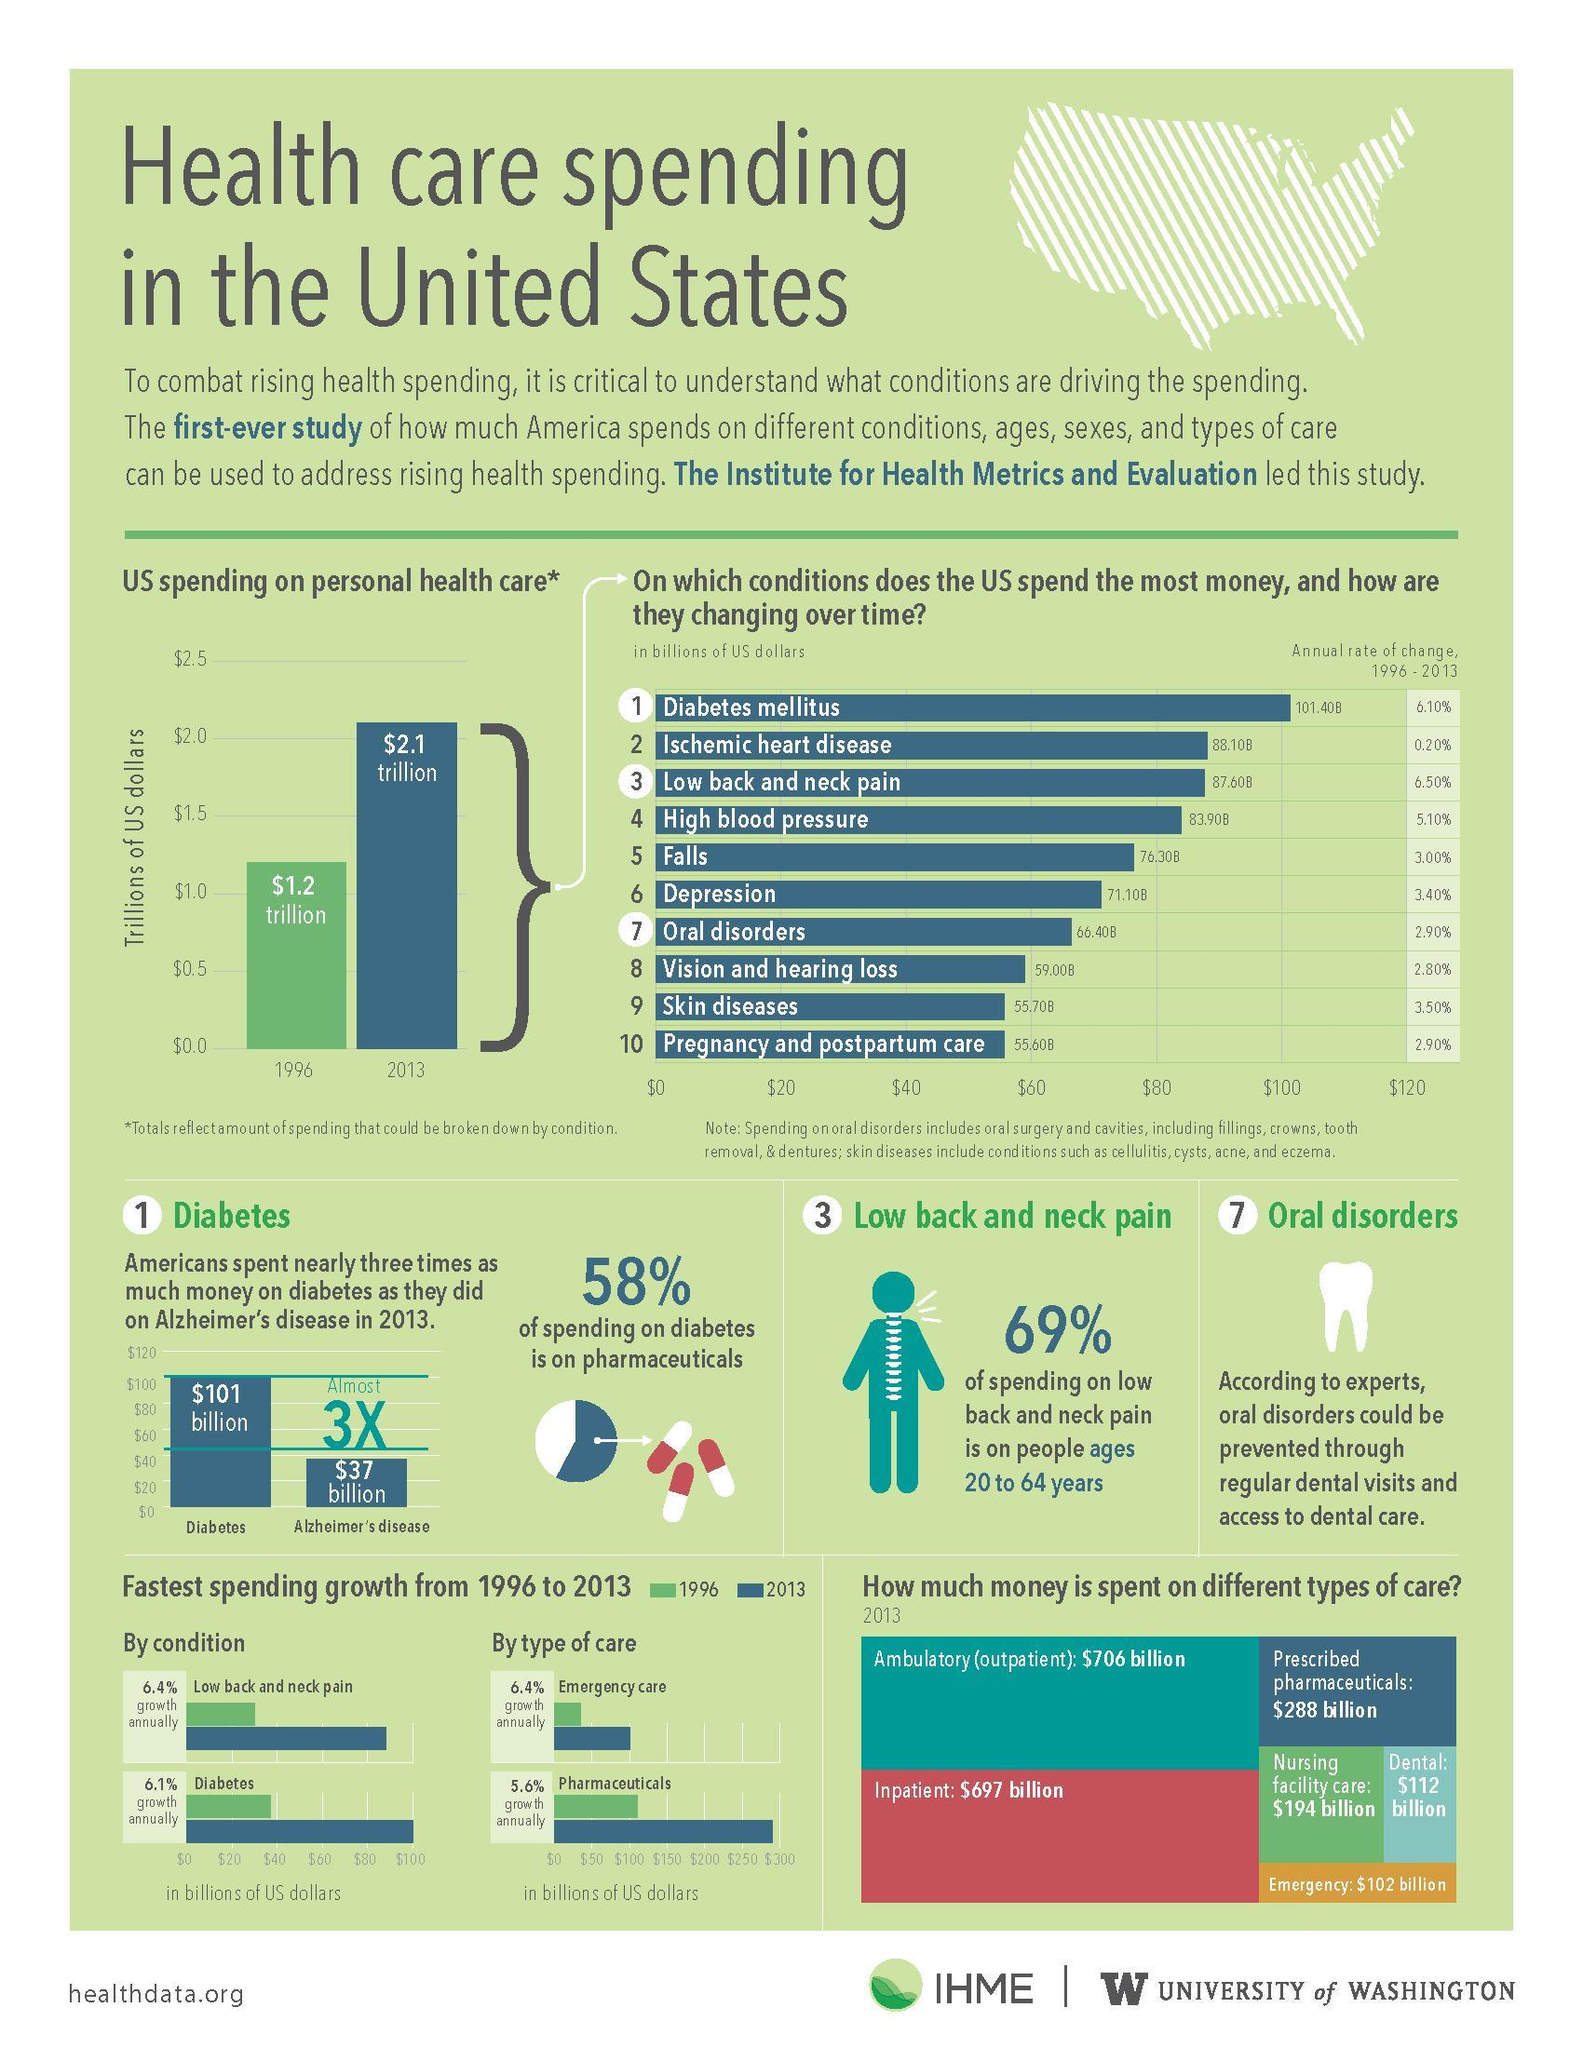How much money is spent on emergency care in the United States in 2013?
Answer the question with a short phrase. $102 billion How much money is spent on nursing facility care in the United States in 2013? $194 billion On which condition does the U.S. spend least money over the period from 1996 - 2013? Pregnancy and postpartum care How much money is spent on inpatient care in the United States in 2013? $679 billion What is the amount of money spent by Americans on Alzheimer's disease in 2013? $37 billion On which condition does the U.S. spend the most money over the period from 1996 - 2013? Diabetes mellitus 